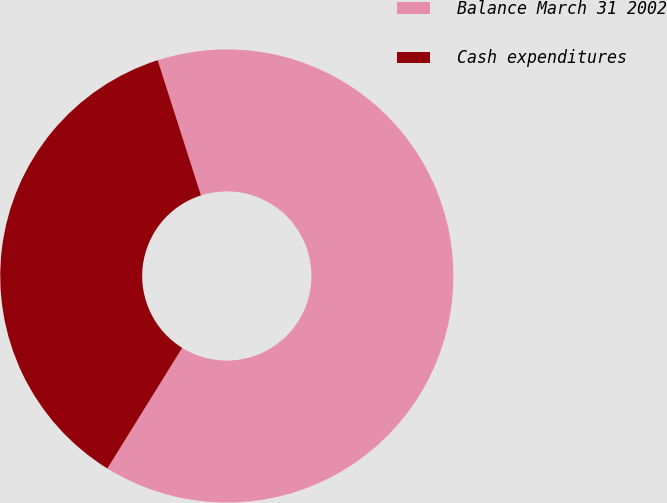<chart> <loc_0><loc_0><loc_500><loc_500><pie_chart><fcel>Balance March 31 2002<fcel>Cash expenditures<nl><fcel>63.77%<fcel>36.23%<nl></chart> 